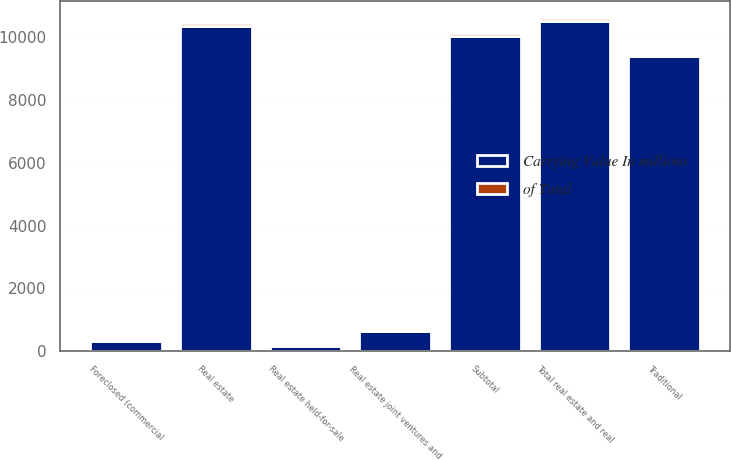Convert chart. <chart><loc_0><loc_0><loc_500><loc_500><stacked_bar_chart><ecel><fcel>Traditional<fcel>Real estate joint ventures and<fcel>Subtotal<fcel>Foreclosed (commercial<fcel>Real estate<fcel>Real estate held-for-sale<fcel>Total real estate and real<nl><fcel>Carrying Value In millions<fcel>9386<fcel>647<fcel>10033<fcel>320<fcel>10353<fcel>172<fcel>10525<nl><fcel>of Total<fcel>89.2<fcel>6.2<fcel>95.4<fcel>3<fcel>98.4<fcel>1.6<fcel>100<nl></chart> 